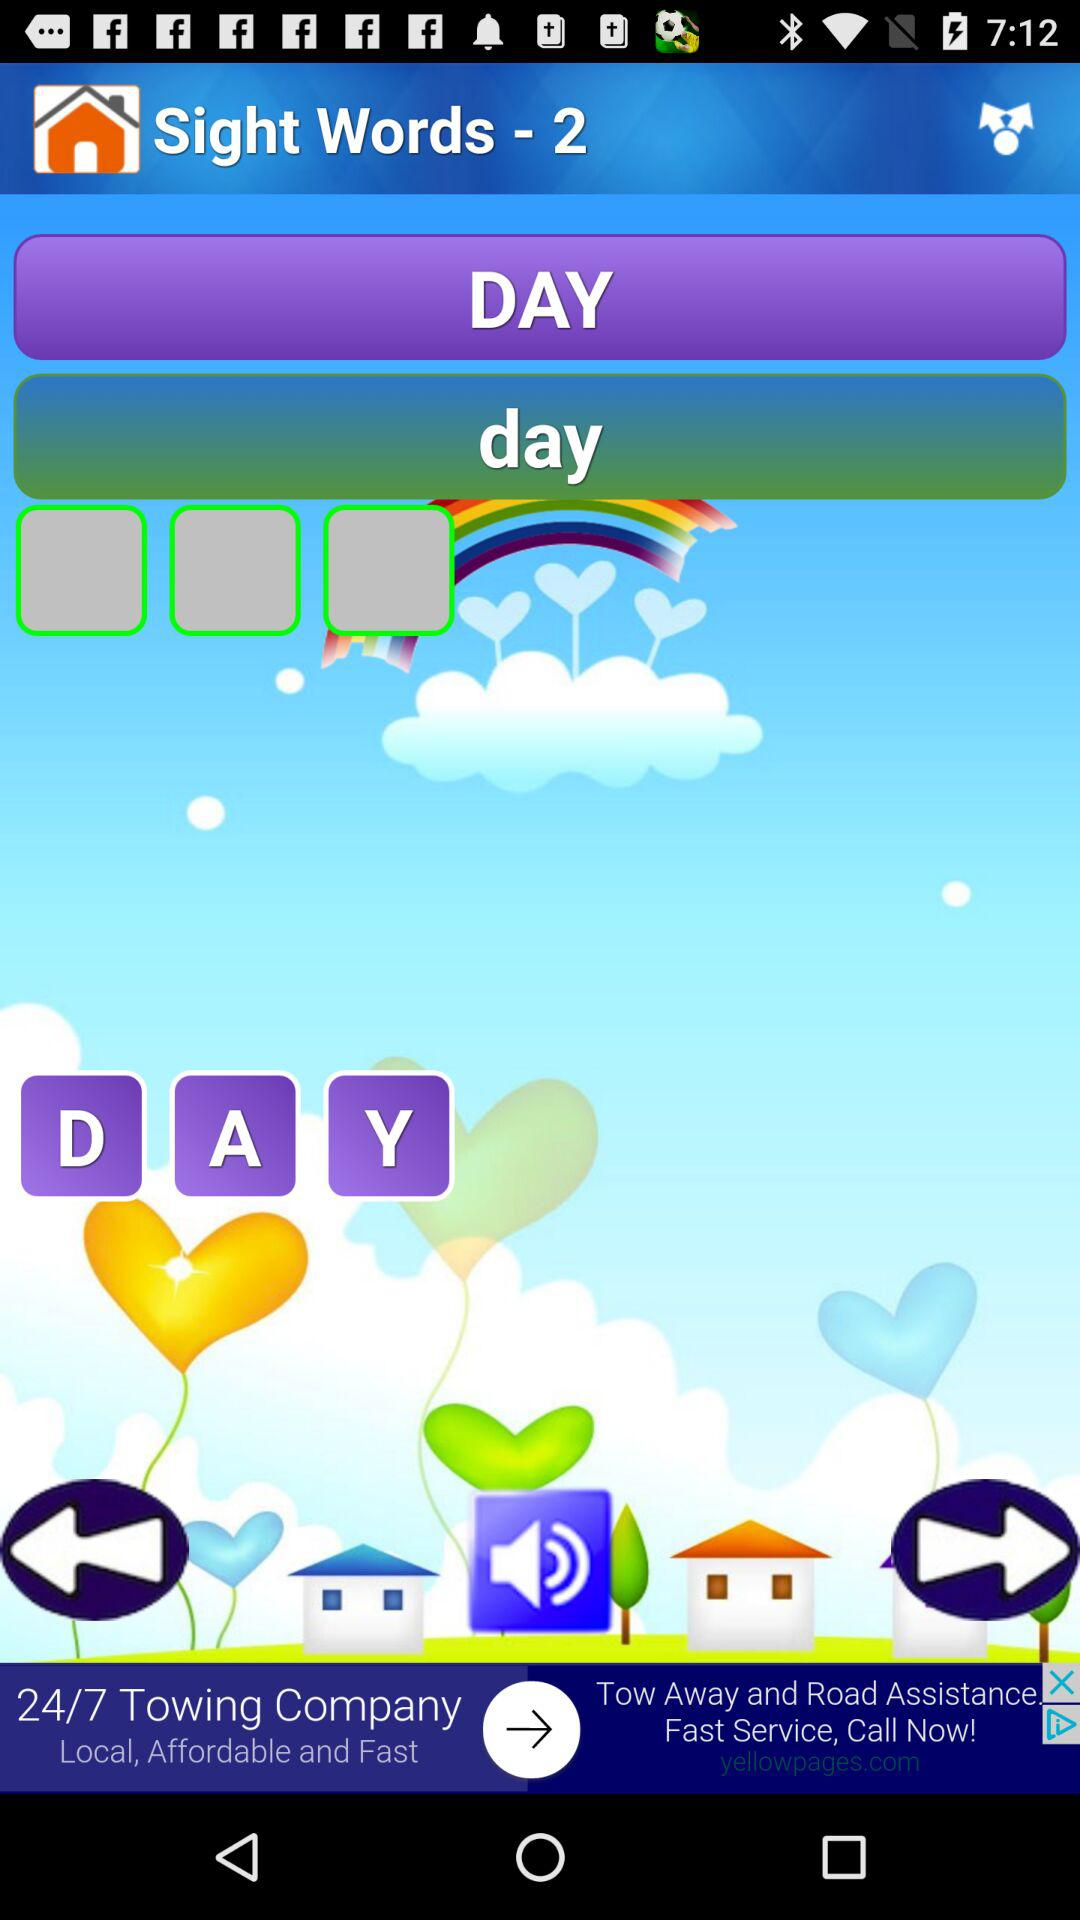What is the version of this application?
When the provided information is insufficient, respond with <no answer>. <no answer> 